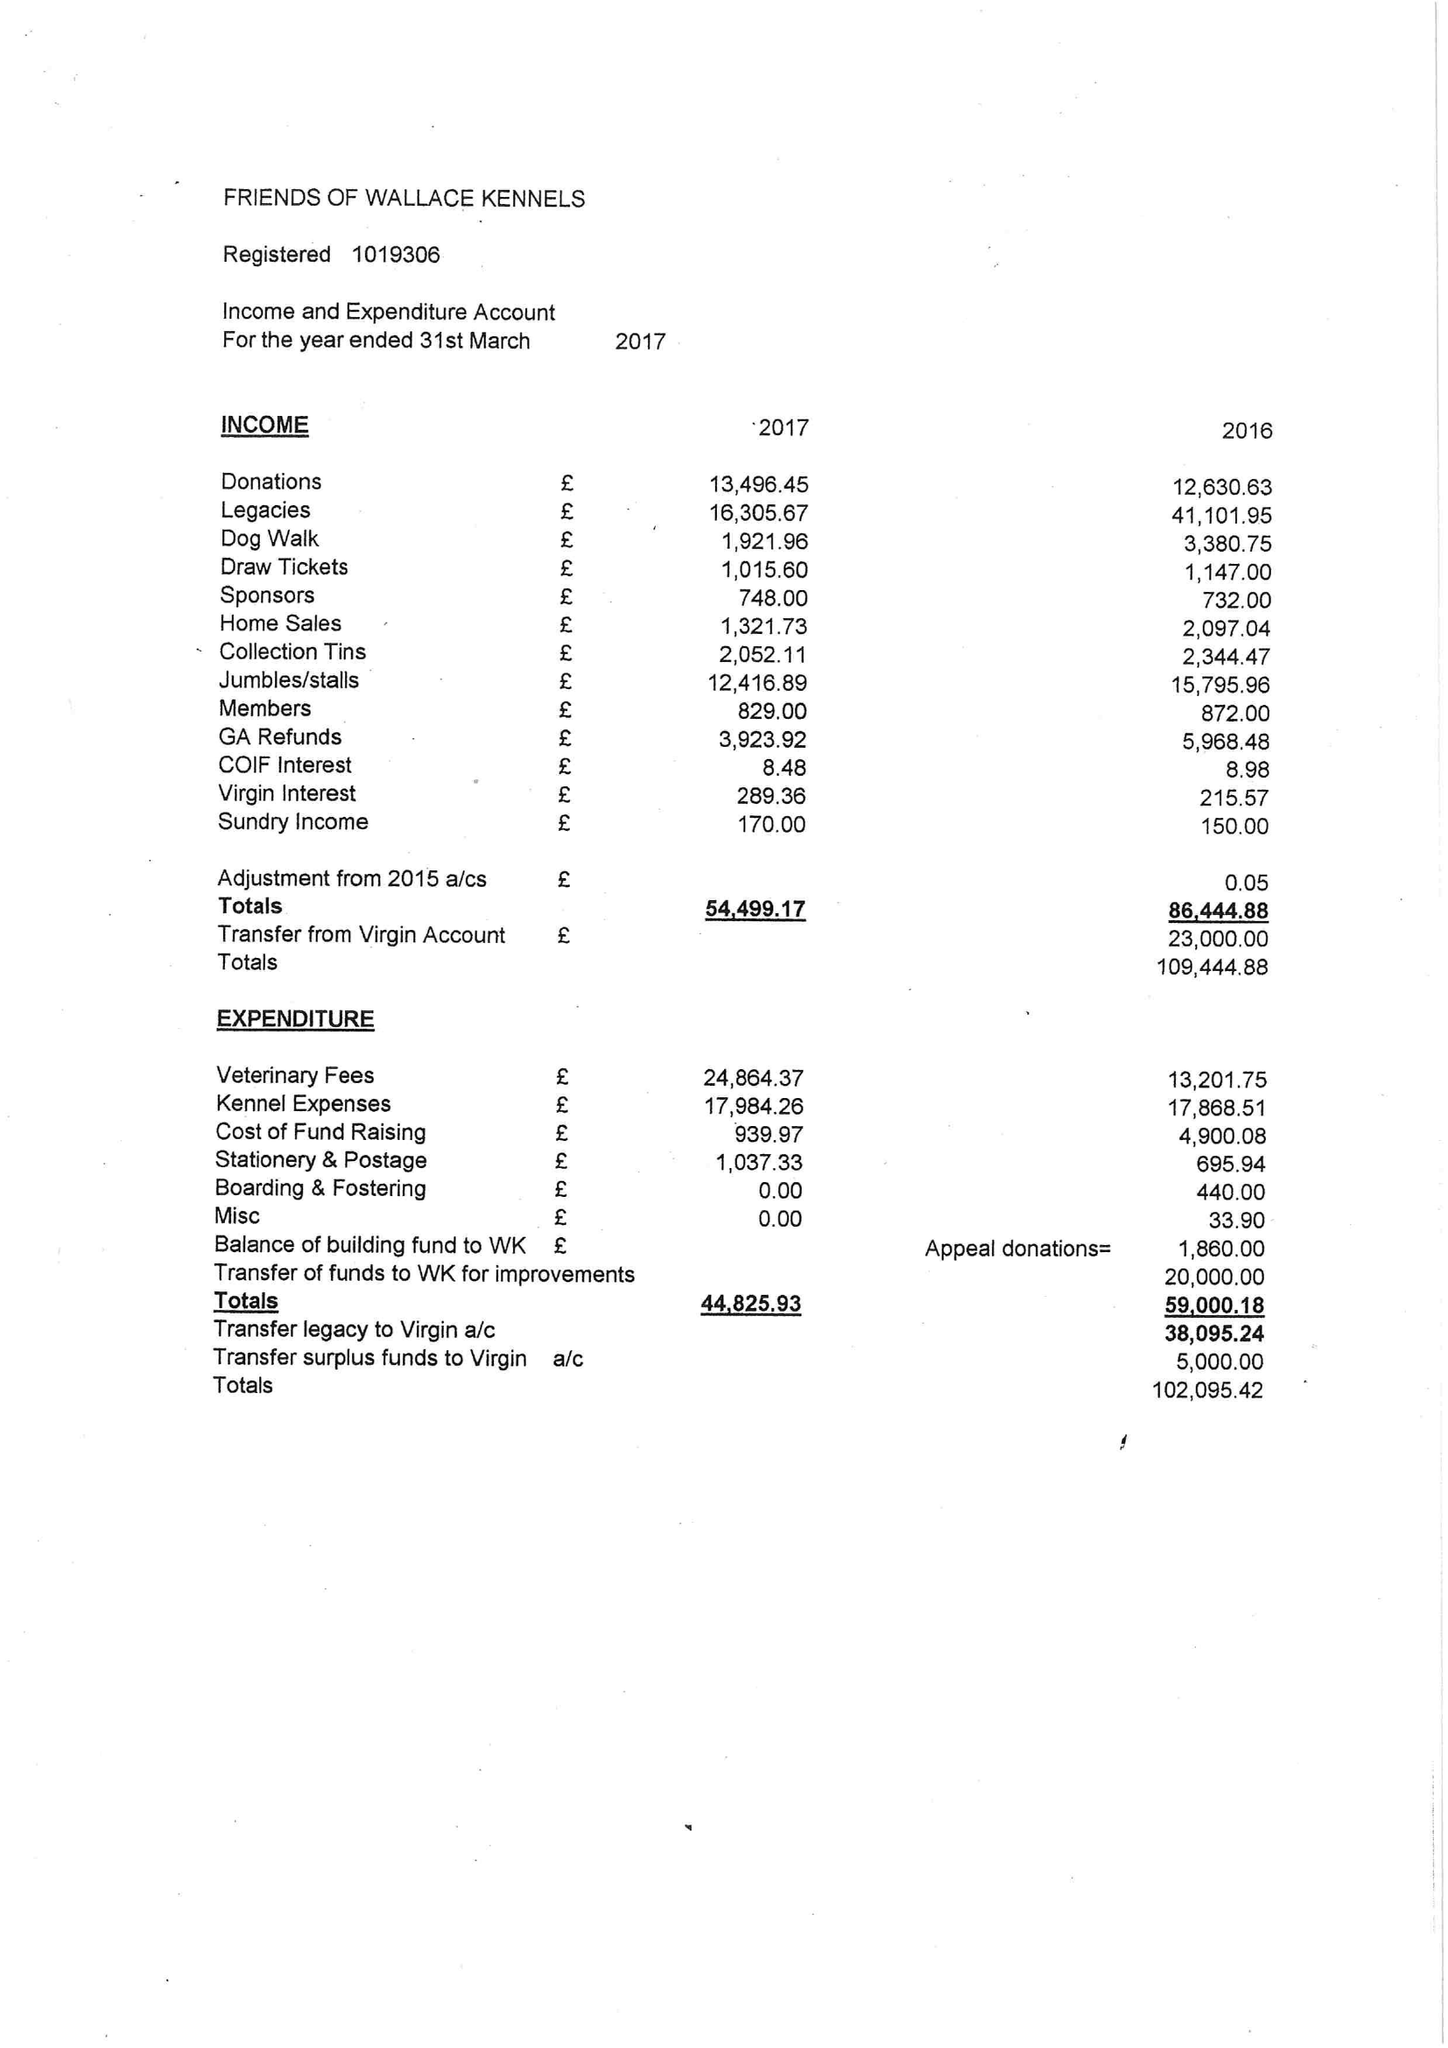What is the value for the address__post_town?
Answer the question using a single word or phrase. BILLERICAY 